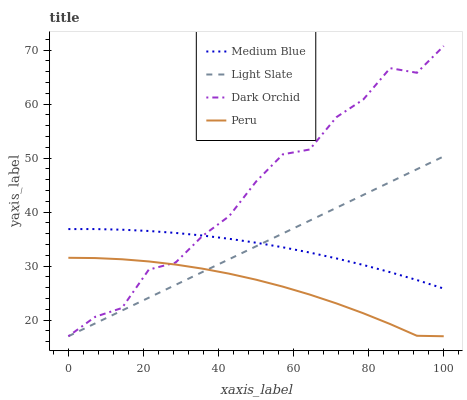Does Medium Blue have the minimum area under the curve?
Answer yes or no. No. Does Medium Blue have the maximum area under the curve?
Answer yes or no. No. Is Medium Blue the smoothest?
Answer yes or no. No. Is Medium Blue the roughest?
Answer yes or no. No. Does Medium Blue have the lowest value?
Answer yes or no. No. Does Medium Blue have the highest value?
Answer yes or no. No. Is Peru less than Medium Blue?
Answer yes or no. Yes. Is Medium Blue greater than Peru?
Answer yes or no. Yes. Does Peru intersect Medium Blue?
Answer yes or no. No. 